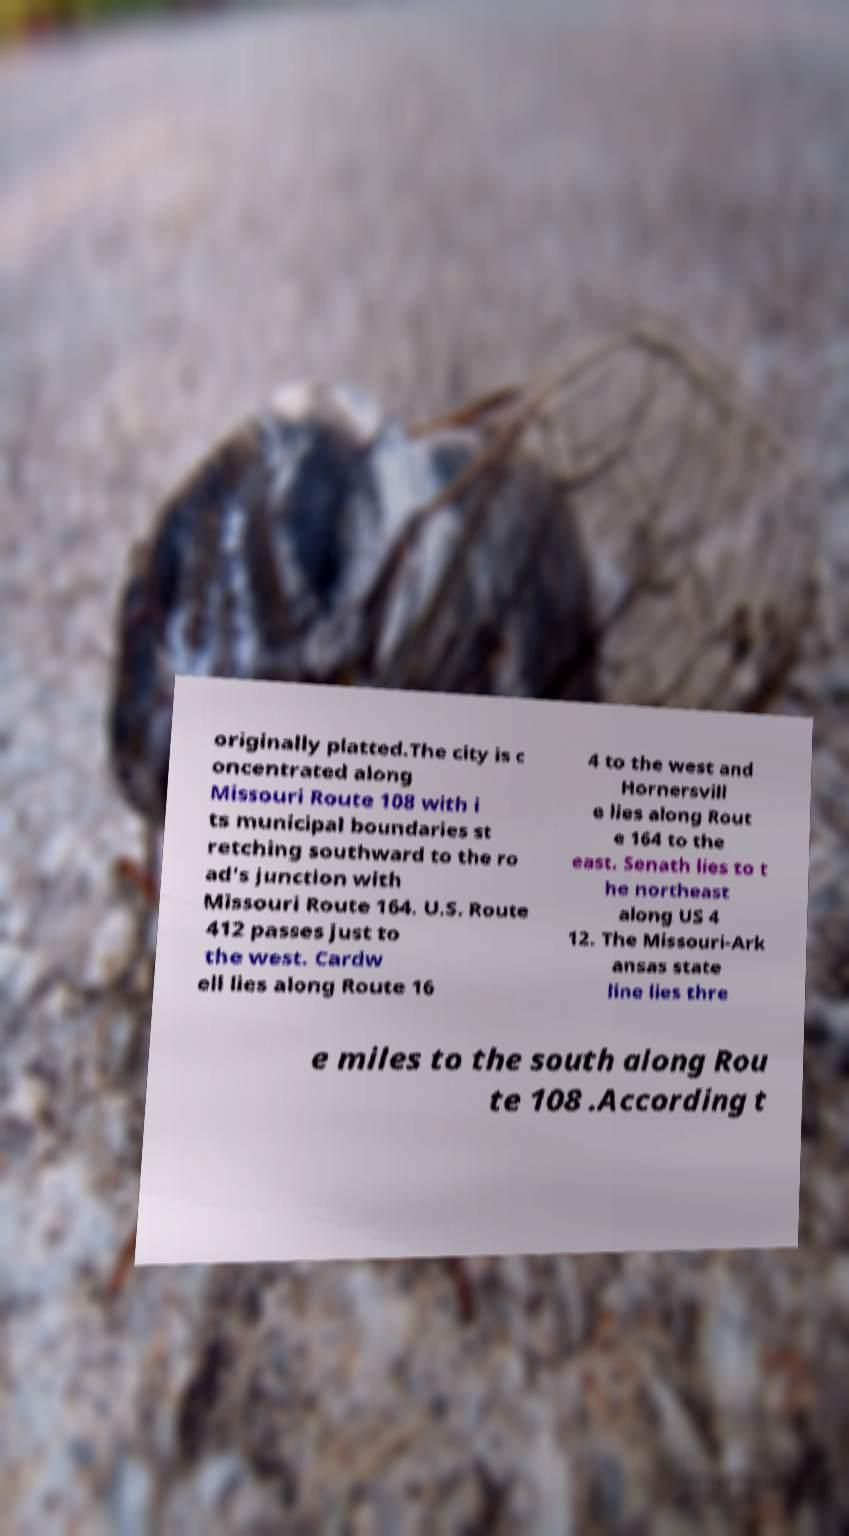Can you accurately transcribe the text from the provided image for me? originally platted.The city is c oncentrated along Missouri Route 108 with i ts municipal boundaries st retching southward to the ro ad's junction with Missouri Route 164. U.S. Route 412 passes just to the west. Cardw ell lies along Route 16 4 to the west and Hornersvill e lies along Rout e 164 to the east. Senath lies to t he northeast along US 4 12. The Missouri-Ark ansas state line lies thre e miles to the south along Rou te 108 .According t 